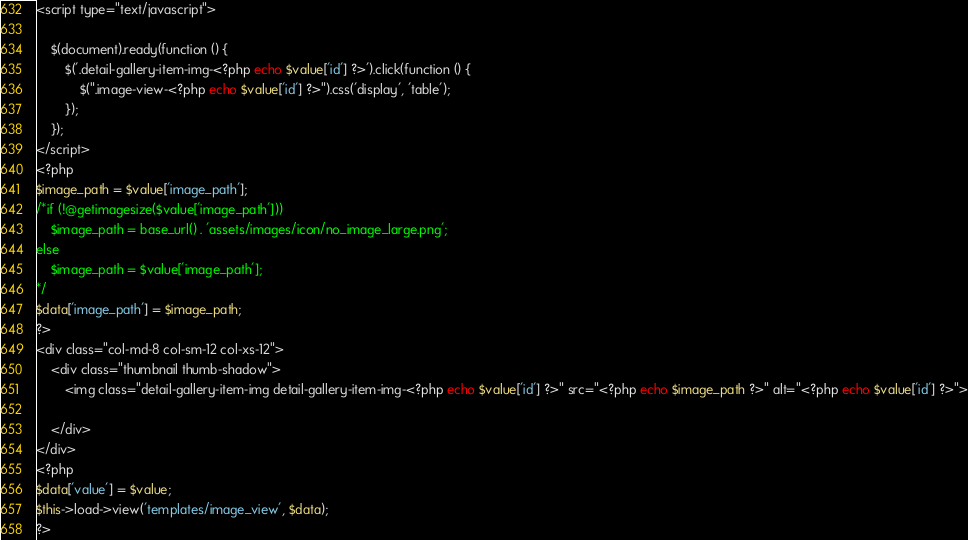<code> <loc_0><loc_0><loc_500><loc_500><_PHP_><script type="text/javascript">

    $(document).ready(function () {
        $('.detail-gallery-item-img-<?php echo $value['id'] ?>').click(function () {
            $(".image-view-<?php echo $value['id'] ?>").css('display', 'table');
        });
    });
</script>
<?php
$image_path = $value['image_path'];
/*if (!@getimagesize($value['image_path']))
    $image_path = base_url() . 'assets/images/icon/no_image_large.png';
else
    $image_path = $value['image_path'];
*/
$data['image_path'] = $image_path;
?>
<div class="col-md-8 col-sm-12 col-xs-12">
    <div class="thumbnail thumb-shadow">
        <img class="detail-gallery-item-img detail-gallery-item-img-<?php echo $value['id'] ?>" src="<?php echo $image_path ?>" alt="<?php echo $value['id'] ?>">

    </div> 
</div>
<?php
$data['value'] = $value;
$this->load->view('templates/image_view', $data);
?></code> 